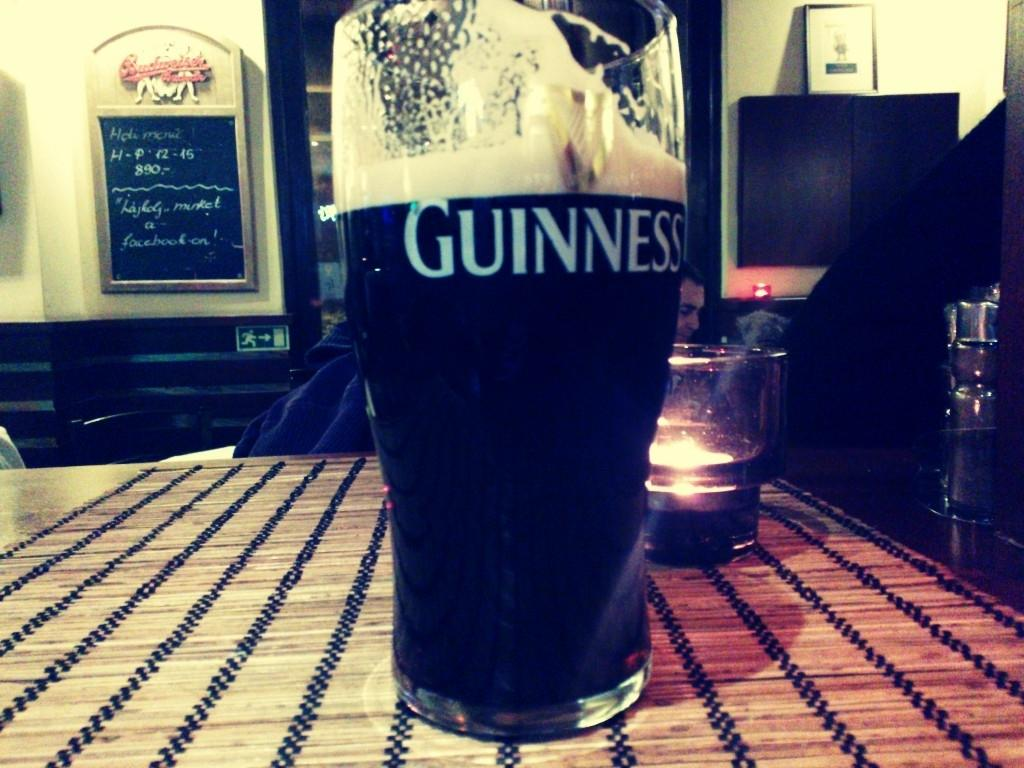<image>
Relay a brief, clear account of the picture shown. a large glass of Guinness sits on a striped table 